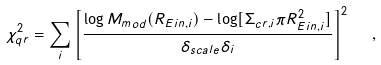<formula> <loc_0><loc_0><loc_500><loc_500>\chi ^ { 2 } _ { q r } = \sum _ { i } \left [ \frac { \log M _ { m o d } ( R _ { E i n , i } ) - \log [ \Sigma _ { c r , i } \pi R _ { E i n , i } ^ { 2 } ] } { \delta _ { s c a l e } \delta _ { i } } \right ] ^ { 2 } \ \ ,</formula> 